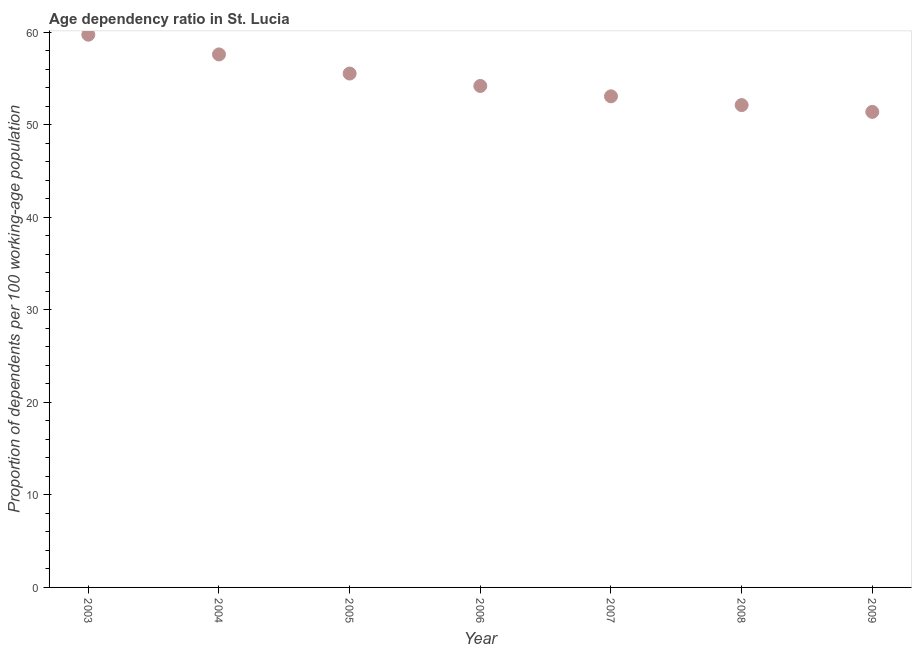What is the age dependency ratio in 2003?
Your answer should be compact. 59.74. Across all years, what is the maximum age dependency ratio?
Offer a terse response. 59.74. Across all years, what is the minimum age dependency ratio?
Offer a very short reply. 51.4. In which year was the age dependency ratio maximum?
Offer a very short reply. 2003. In which year was the age dependency ratio minimum?
Keep it short and to the point. 2009. What is the sum of the age dependency ratio?
Provide a short and direct response. 383.71. What is the difference between the age dependency ratio in 2005 and 2006?
Make the answer very short. 1.34. What is the average age dependency ratio per year?
Offer a very short reply. 54.82. What is the median age dependency ratio?
Offer a very short reply. 54.2. Do a majority of the years between 2005 and 2003 (inclusive) have age dependency ratio greater than 58 ?
Your answer should be compact. No. What is the ratio of the age dependency ratio in 2008 to that in 2009?
Your answer should be compact. 1.01. Is the age dependency ratio in 2003 less than that in 2009?
Offer a terse response. No. Is the difference between the age dependency ratio in 2005 and 2006 greater than the difference between any two years?
Your answer should be very brief. No. What is the difference between the highest and the second highest age dependency ratio?
Make the answer very short. 2.13. Is the sum of the age dependency ratio in 2007 and 2009 greater than the maximum age dependency ratio across all years?
Keep it short and to the point. Yes. What is the difference between the highest and the lowest age dependency ratio?
Give a very brief answer. 8.35. In how many years, is the age dependency ratio greater than the average age dependency ratio taken over all years?
Ensure brevity in your answer.  3. How many dotlines are there?
Give a very brief answer. 1. How many years are there in the graph?
Your response must be concise. 7. Are the values on the major ticks of Y-axis written in scientific E-notation?
Offer a terse response. No. What is the title of the graph?
Provide a succinct answer. Age dependency ratio in St. Lucia. What is the label or title of the Y-axis?
Provide a short and direct response. Proportion of dependents per 100 working-age population. What is the Proportion of dependents per 100 working-age population in 2003?
Provide a succinct answer. 59.74. What is the Proportion of dependents per 100 working-age population in 2004?
Your response must be concise. 57.61. What is the Proportion of dependents per 100 working-age population in 2005?
Your answer should be very brief. 55.54. What is the Proportion of dependents per 100 working-age population in 2006?
Ensure brevity in your answer.  54.2. What is the Proportion of dependents per 100 working-age population in 2007?
Give a very brief answer. 53.08. What is the Proportion of dependents per 100 working-age population in 2008?
Keep it short and to the point. 52.13. What is the Proportion of dependents per 100 working-age population in 2009?
Provide a succinct answer. 51.4. What is the difference between the Proportion of dependents per 100 working-age population in 2003 and 2004?
Keep it short and to the point. 2.13. What is the difference between the Proportion of dependents per 100 working-age population in 2003 and 2005?
Give a very brief answer. 4.2. What is the difference between the Proportion of dependents per 100 working-age population in 2003 and 2006?
Ensure brevity in your answer.  5.54. What is the difference between the Proportion of dependents per 100 working-age population in 2003 and 2007?
Your answer should be very brief. 6.66. What is the difference between the Proportion of dependents per 100 working-age population in 2003 and 2008?
Give a very brief answer. 7.61. What is the difference between the Proportion of dependents per 100 working-age population in 2003 and 2009?
Keep it short and to the point. 8.35. What is the difference between the Proportion of dependents per 100 working-age population in 2004 and 2005?
Provide a succinct answer. 2.07. What is the difference between the Proportion of dependents per 100 working-age population in 2004 and 2006?
Provide a short and direct response. 3.41. What is the difference between the Proportion of dependents per 100 working-age population in 2004 and 2007?
Give a very brief answer. 4.53. What is the difference between the Proportion of dependents per 100 working-age population in 2004 and 2008?
Your answer should be very brief. 5.48. What is the difference between the Proportion of dependents per 100 working-age population in 2004 and 2009?
Your answer should be compact. 6.21. What is the difference between the Proportion of dependents per 100 working-age population in 2005 and 2006?
Give a very brief answer. 1.34. What is the difference between the Proportion of dependents per 100 working-age population in 2005 and 2007?
Provide a succinct answer. 2.46. What is the difference between the Proportion of dependents per 100 working-age population in 2005 and 2008?
Your answer should be very brief. 3.41. What is the difference between the Proportion of dependents per 100 working-age population in 2005 and 2009?
Your answer should be very brief. 4.14. What is the difference between the Proportion of dependents per 100 working-age population in 2006 and 2007?
Provide a succinct answer. 1.12. What is the difference between the Proportion of dependents per 100 working-age population in 2006 and 2008?
Offer a very short reply. 2.07. What is the difference between the Proportion of dependents per 100 working-age population in 2006 and 2009?
Make the answer very short. 2.8. What is the difference between the Proportion of dependents per 100 working-age population in 2007 and 2008?
Provide a short and direct response. 0.95. What is the difference between the Proportion of dependents per 100 working-age population in 2007 and 2009?
Ensure brevity in your answer.  1.68. What is the difference between the Proportion of dependents per 100 working-age population in 2008 and 2009?
Provide a short and direct response. 0.74. What is the ratio of the Proportion of dependents per 100 working-age population in 2003 to that in 2005?
Your answer should be compact. 1.08. What is the ratio of the Proportion of dependents per 100 working-age population in 2003 to that in 2006?
Provide a succinct answer. 1.1. What is the ratio of the Proportion of dependents per 100 working-age population in 2003 to that in 2007?
Your response must be concise. 1.13. What is the ratio of the Proportion of dependents per 100 working-age population in 2003 to that in 2008?
Provide a succinct answer. 1.15. What is the ratio of the Proportion of dependents per 100 working-age population in 2003 to that in 2009?
Provide a succinct answer. 1.16. What is the ratio of the Proportion of dependents per 100 working-age population in 2004 to that in 2006?
Your answer should be compact. 1.06. What is the ratio of the Proportion of dependents per 100 working-age population in 2004 to that in 2007?
Make the answer very short. 1.08. What is the ratio of the Proportion of dependents per 100 working-age population in 2004 to that in 2008?
Keep it short and to the point. 1.1. What is the ratio of the Proportion of dependents per 100 working-age population in 2004 to that in 2009?
Your answer should be compact. 1.12. What is the ratio of the Proportion of dependents per 100 working-age population in 2005 to that in 2006?
Offer a very short reply. 1.02. What is the ratio of the Proportion of dependents per 100 working-age population in 2005 to that in 2007?
Offer a very short reply. 1.05. What is the ratio of the Proportion of dependents per 100 working-age population in 2005 to that in 2008?
Provide a short and direct response. 1.06. What is the ratio of the Proportion of dependents per 100 working-age population in 2005 to that in 2009?
Offer a terse response. 1.08. What is the ratio of the Proportion of dependents per 100 working-age population in 2006 to that in 2007?
Give a very brief answer. 1.02. What is the ratio of the Proportion of dependents per 100 working-age population in 2006 to that in 2009?
Offer a terse response. 1.05. What is the ratio of the Proportion of dependents per 100 working-age population in 2007 to that in 2009?
Give a very brief answer. 1.03. What is the ratio of the Proportion of dependents per 100 working-age population in 2008 to that in 2009?
Make the answer very short. 1.01. 